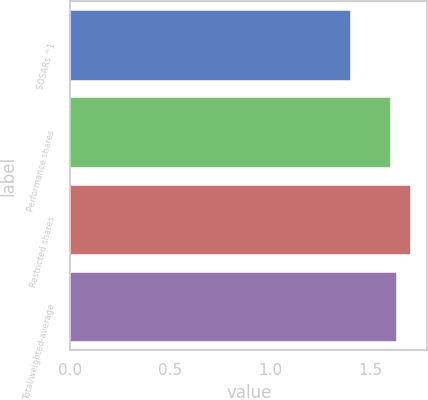<chart> <loc_0><loc_0><loc_500><loc_500><bar_chart><fcel>SOSARs ^1<fcel>Performance shares<fcel>Restricted shares<fcel>Total/weighted-average<nl><fcel>1.4<fcel>1.6<fcel>1.7<fcel>1.63<nl></chart> 